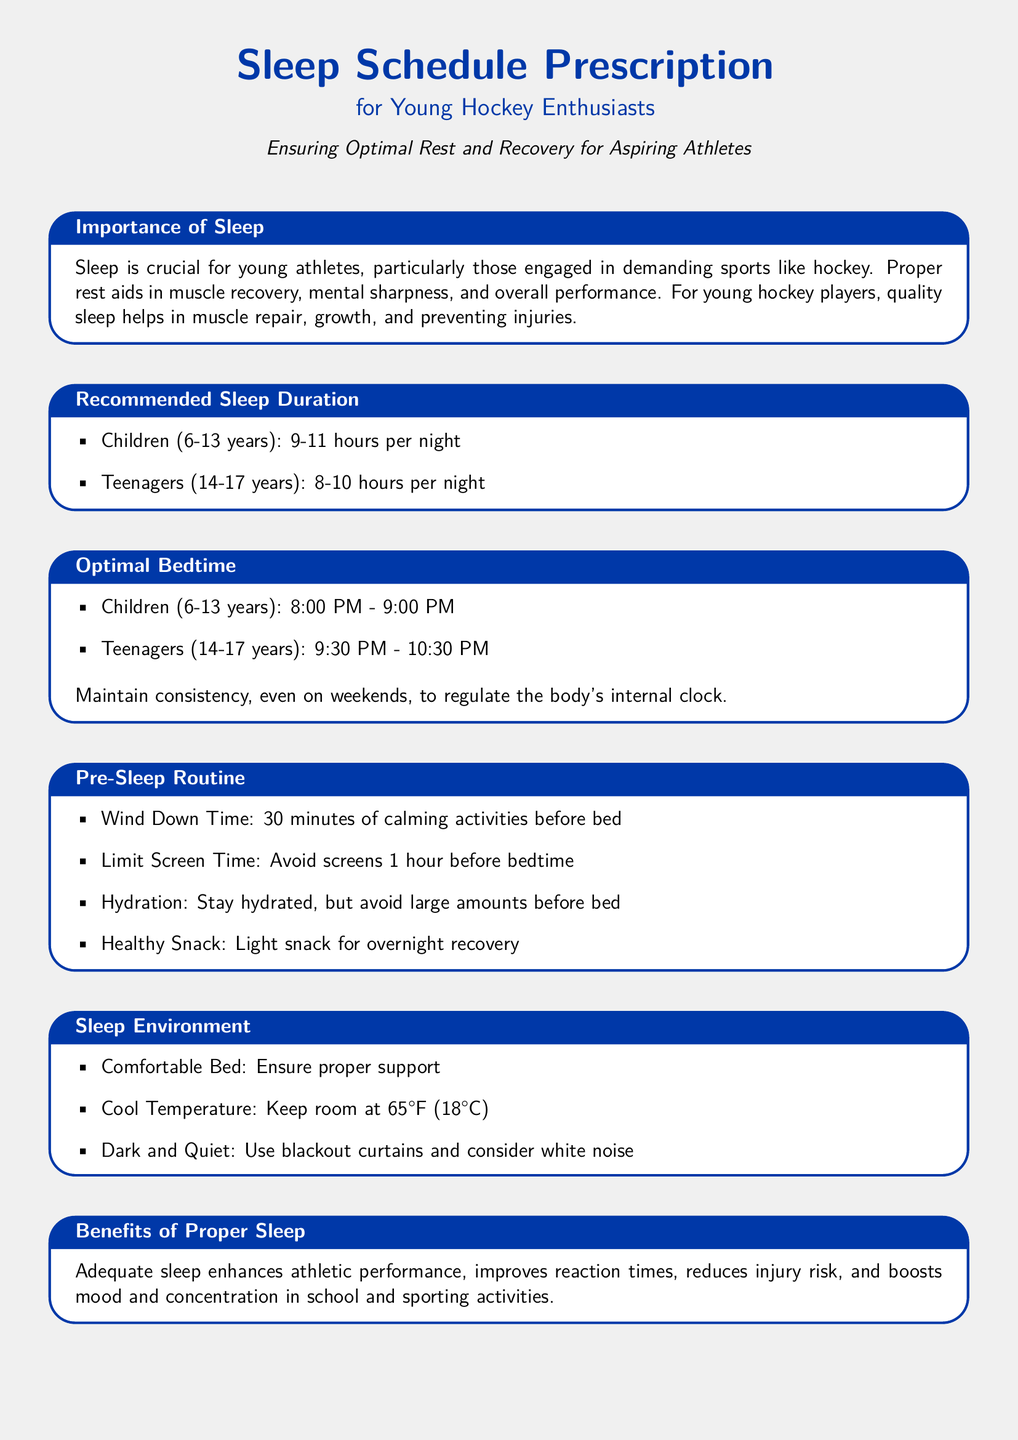What is the recommended sleep duration for children? The document states that children aged 6-13 should get 9-11 hours of sleep per night.
Answer: 9-11 hours What time is the optimal bedtime for teenagers? According to the document, teenagers aged 14-17 should go to bed between 9:30 PM and 10:30 PM.
Answer: 9:30 PM - 10:30 PM Why is sleep important for young athletes? The document highlights that proper rest aids in muscle recovery, mental sharpness, and overall performance for young athletes.
Answer: Muscle recovery and mental sharpness What is advised during the wind-down time before bed? The document suggests engaging in calming activities for 30 minutes before sleeping.
Answer: Calming activities for 30 minutes What temperature should the sleep environment be? The recommended room temperature for optimal sleep environment is 65°F (18°C).
Answer: 65°F (18°C) What should be limited 1 hour before bedtime? The document advises to avoid screens the hour prior to sleeping.
Answer: Screens How does proper sleep affect athletic performance? The document states that adequate sleep enhances performance and reduces injury risk.
Answer: Enhances performance What is a recommended pre-sleep snack approach? The document recommends having a light snack for overnight recovery.
Answer: Light snack What should be used to ensure a dark sleep environment? The document suggests using blackout curtains.
Answer: Blackout curtains How many hours of sleep should teenagers get? Teenagers aged 14-17 should aim for 8-10 hours of sleep per night according to the document.
Answer: 8-10 hours 